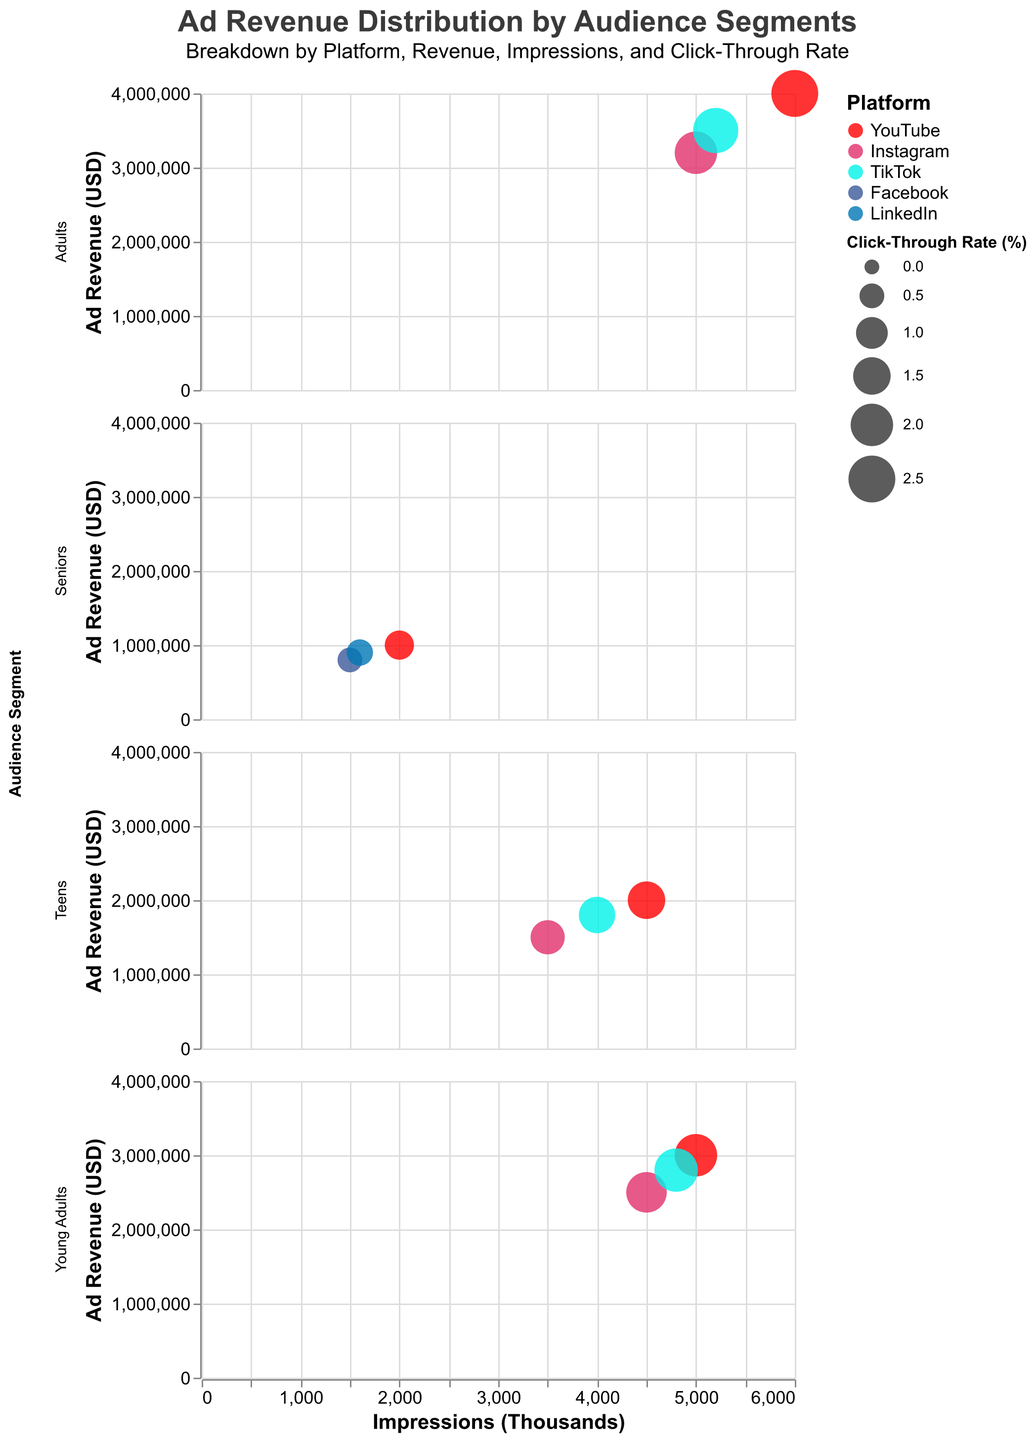What is the title of the figure? The title of a figure is typically found at the top and provides an overview of what the visualization represents. In this case, the provided code specifies the title of the figure.
Answer: Ad Revenue Distribution by Audience Segments What platforms are used to display ad revenue for the Seniors audience segment? To find which platforms are used in the Seniors audience segment, look at the corresponding subplot row and identify the different colored bubbles, each representing a platform.
Answer: YouTube, Facebook, LinkedIn Which audience segment has the highest ad revenue on YouTube? To determine this, look at the YouTube bubbles across the different audience segments and compare their positions on the y-axis, which represents ad revenue.
Answer: Adults Among the platforms targeting Teens, which one has the highest click-through rate? Check the size of the bubbles, as the size represents the click-through rate, and find the largest bubble in the Teens section.
Answer: TikTok How does the click-through rate for Instagram compare between Young Adults and Adults? Compare the sizes of the Instagram bubbles for the Young Adults and Adults segments. Larger bubbles represent higher click-through rates.
Answer: Adults have a higher click-through rate Which audience segment has the lowest impressions on Instagram? Locate the Instagram bubbles in each audience segment's row and identify the bubble with the lowest position on the x-axis, representing impressions.
Answer: Teens What is the total ad revenue for TikTok across all audience segments? Sum the y-axis values for all TikTok bubbles across the different audience segments. Teens: 1800000, Young Adults: 2800000, Adults: 3500000. Total = 1800000 + 2800000 + 3500000
Answer: 8100000 What is the difference in ad revenue between YouTube and LinkedIn for Seniors? Identify the ad revenue values for YouTube and LinkedIn in the Seniors segment and subtract the smaller value from the larger one. Seniors - YouTube: 1000000, LinkedIn: 900000. Difference = 1000000 - 900000
Answer: 100000 Which platform has the highest click-through rate for the Adults audience segment? Compare the sizes of the bubbles for the Adults segment, identifying the largest bubble to determine the highest click-through rate platform.
Answer: YouTube 